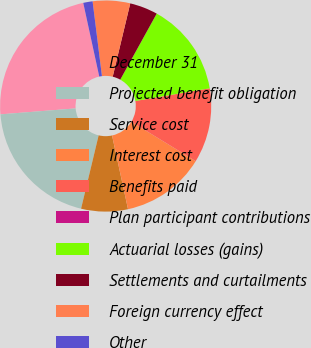Convert chart. <chart><loc_0><loc_0><loc_500><loc_500><pie_chart><fcel>December 31<fcel>Projected benefit obligation<fcel>Service cost<fcel>Interest cost<fcel>Benefits paid<fcel>Plan participant contributions<fcel>Actuarial losses (gains)<fcel>Settlements and curtailments<fcel>Foreign currency effect<fcel>Other<nl><fcel>22.85%<fcel>20.0%<fcel>7.14%<fcel>12.86%<fcel>11.43%<fcel>0.0%<fcel>14.28%<fcel>4.29%<fcel>5.72%<fcel>1.43%<nl></chart> 